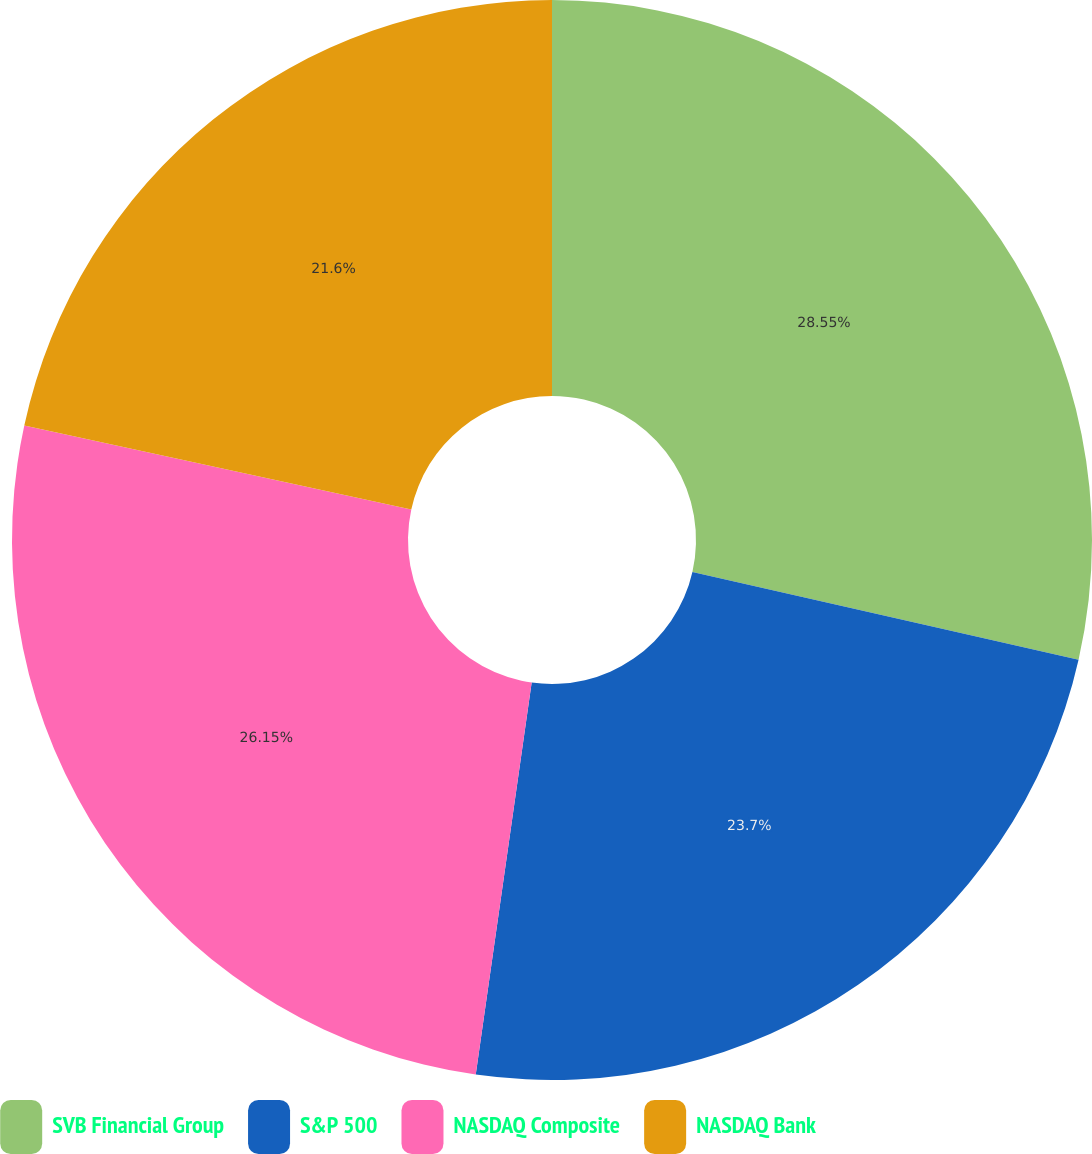Convert chart. <chart><loc_0><loc_0><loc_500><loc_500><pie_chart><fcel>SVB Financial Group<fcel>S&P 500<fcel>NASDAQ Composite<fcel>NASDAQ Bank<nl><fcel>28.56%<fcel>23.7%<fcel>26.15%<fcel>21.6%<nl></chart> 